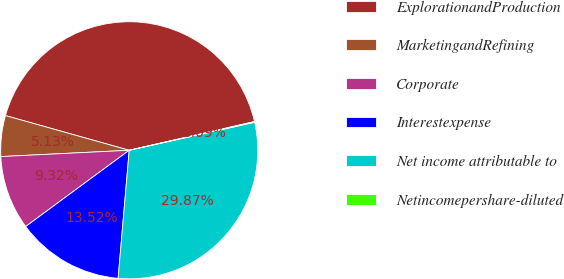<chart> <loc_0><loc_0><loc_500><loc_500><pie_chart><fcel>ExplorationandProduction<fcel>MarketingandRefining<fcel>Corporate<fcel>Interestexpense<fcel>Net income attributable to<fcel>Netincomepershare-diluted<nl><fcel>42.06%<fcel>5.13%<fcel>9.32%<fcel>13.52%<fcel>29.87%<fcel>0.09%<nl></chart> 